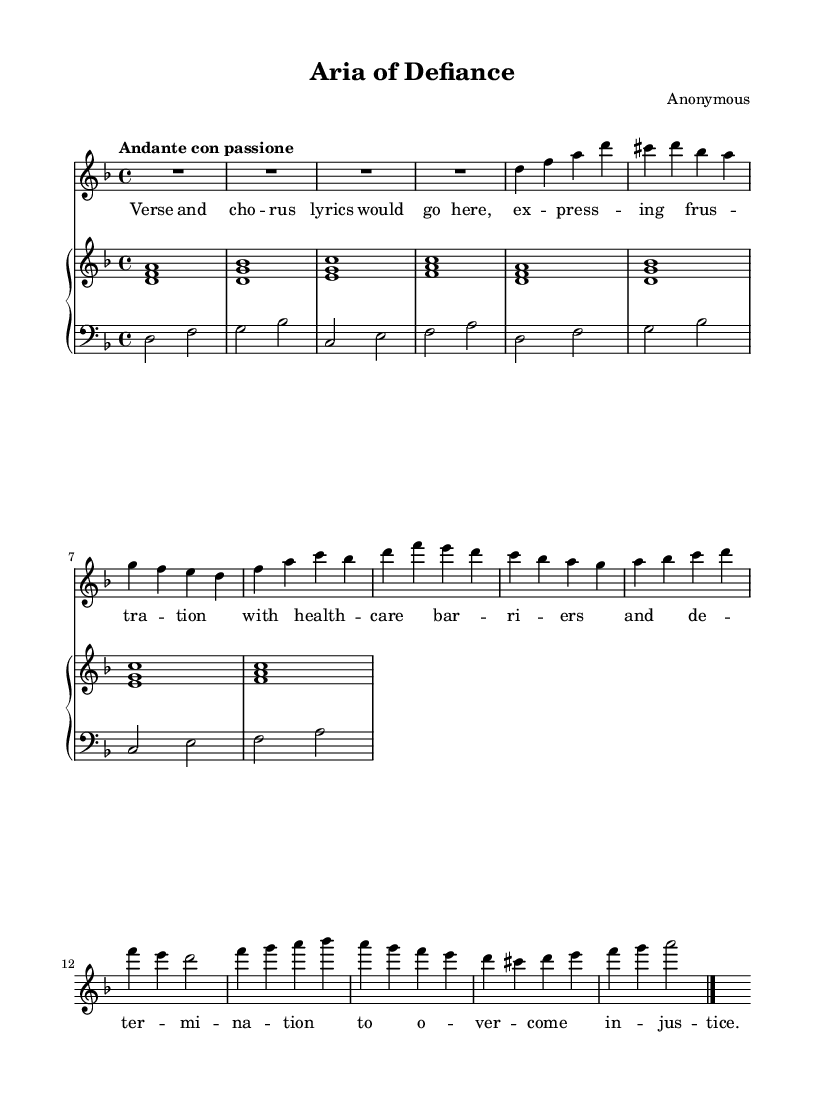What is the key signature of this music? The key signature is indicated at the beginning of the music. In this case, it shows two flats, which corresponds to the key of D minor.
Answer: D minor What is the time signature of the piece? The time signature is located right after the key signature. Here, it shows "4/4", meaning there are four beats in each measure and a quarter note receives one beat.
Answer: 4/4 What is the tempo marking for the piece? The tempo marking is provided at the start of the music, indicating the speed. In this case, "Andante con passione" suggests a moderately slow tempo with a sense of passion.
Answer: Andante con passione How many measures are in the soprano section? By counting the distinct groupings of notes and rests in the soprano line, we see that there are eight measures in total.
Answer: 8 What is the first note of the soprano line? The first note can be identified as 'R1', which stands for a whole rest, so the first note that sounds is the first 'd' in the next measure.
Answer: d What type of accompaniment is present in the piano section? The piano part consists of chords primarily played, with both right-hand and left-hand parts indicating a harmonically rich accompaniment that supports the melody.
Answer: Chords What does the lyric indicate about the thematic content? The lyrics express frustration regarding healthcare barriers and determination to overcome injustice, suggesting a narrative of personal struggle within the aria.
Answer: Frustration with healthcare barriers 